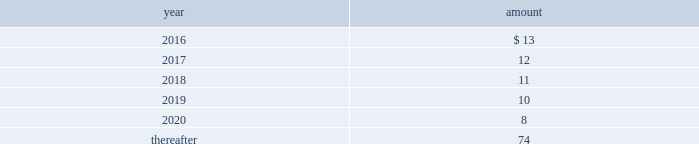Long-term liabilities .
The value of the company 2019s deferred compensation obligations is based on the market value of the participants 2019 notional investment accounts .
The notional investments are comprised primarily of mutual funds , which are based on observable market prices .
Mark-to-market derivative asset and liability 2014the company utilizes fixed-to-floating interest-rate swaps , typically designated as fair-value hedges , to achieve a targeted level of variable-rate debt as a percentage of total debt .
The company also employs derivative financial instruments in the form of variable-to-fixed interest rate swaps , classified as economic hedges , in order to fix the interest cost on some of its variable-rate debt .
The company uses a calculation of future cash inflows and estimated future outflows , which are discounted , to determine the current fair value .
Additional inputs to the present value calculation include the contract terms , counterparty credit risk , interest rates and market volatility .
Other investments 2014other investments primarily represent money market funds used for active employee benefits .
The company includes other investments in other current assets .
Note 18 : leases the company has entered into operating leases involving certain facilities and equipment .
Rental expenses under operating leases were $ 21 for 2015 , $ 22 for 2014 and $ 23 for 2013 .
The operating leases for facilities will expire over the next 25 years and the operating leases for equipment will expire over the next five years .
Certain operating leases have renewal options ranging from one to five years .
The minimum annual future rental commitment under operating leases that have initial or remaining non- cancelable lease terms over the next five years and thereafter are as follows: .
The company has a series of agreements with various public entities ( the 201cpartners 201d ) to establish certain joint ventures , commonly referred to as 201cpublic-private partnerships . 201d under the public-private partnerships , the company constructed utility plant , financed by the company and the partners constructed utility plant ( connected to the company 2019s property ) , financed by the partners .
The company agreed to transfer and convey some of its real and personal property to the partners in exchange for an equal principal amount of industrial development bonds ( 201cidbs 201d ) , issued by the partners under a state industrial development bond and commercial development act .
The company leased back the total facilities , including portions funded by both the company and the partners , under leases for a period of 40 years .
The leases related to the portion of the facilities funded by the company have required payments from the company to the partners that approximate the payments required by the terms of the idbs from the partners to the company ( as the holder of the idbs ) .
As the ownership of the portion of the facilities constructed by the company will revert back to the company at the end of the lease , the company has recorded these as capital leases .
The lease obligation and the receivable for the principal amount of the idbs are presented by the company on a net basis .
The gross cost of the facilities funded by the company recognized as a capital lease asset was $ 156 and $ 157 as of december 31 , 2015 and 2014 , respectively , which is presented in property , plant and equipment in the accompanying consolidated balance sheets .
The future payments under the lease obligations are equal to and offset by the payments receivable under the idbs. .
What was the change in annual rental expenses from 2015 to 2016 in dollars? 
Rationale: the change from one period to another is the difference between the 2 periods
Computations: (21 - 13)
Answer: 8.0. 